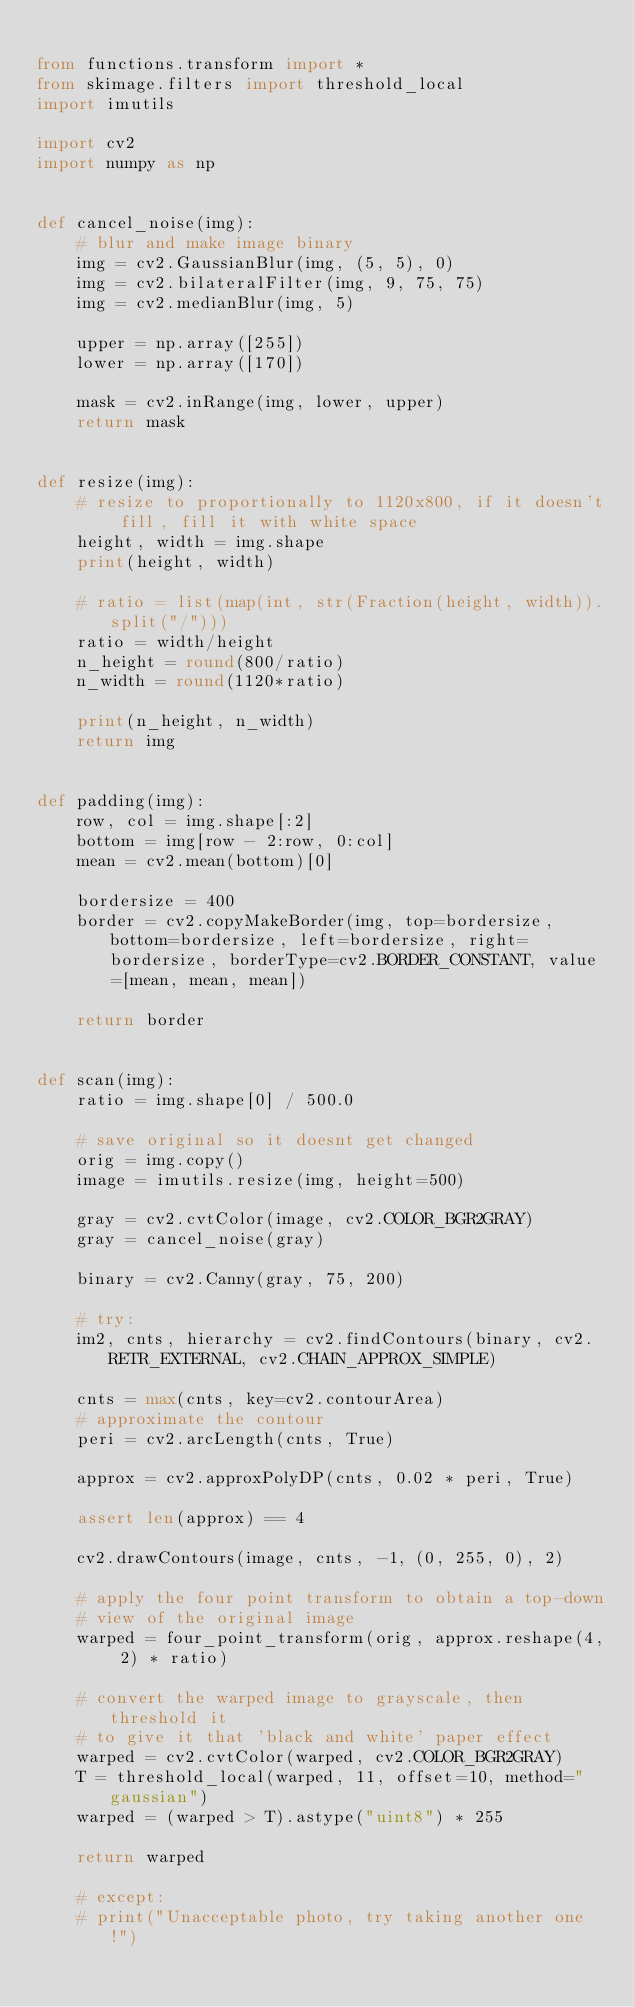<code> <loc_0><loc_0><loc_500><loc_500><_Python_>
from functions.transform import *
from skimage.filters import threshold_local
import imutils

import cv2
import numpy as np


def cancel_noise(img):
    # blur and make image binary
    img = cv2.GaussianBlur(img, (5, 5), 0)
    img = cv2.bilateralFilter(img, 9, 75, 75)
    img = cv2.medianBlur(img, 5)

    upper = np.array([255])
    lower = np.array([170])

    mask = cv2.inRange(img, lower, upper)
    return mask


def resize(img):
    # resize to proportionally to 1120x800, if it doesn't fill, fill it with white space
    height, width = img.shape
    print(height, width)

    # ratio = list(map(int, str(Fraction(height, width)).split("/")))
    ratio = width/height
    n_height = round(800/ratio)
    n_width = round(1120*ratio)

    print(n_height, n_width)
    return img


def padding(img):
    row, col = img.shape[:2]
    bottom = img[row - 2:row, 0:col]
    mean = cv2.mean(bottom)[0]

    bordersize = 400
    border = cv2.copyMakeBorder(img, top=bordersize, bottom=bordersize, left=bordersize, right=bordersize, borderType=cv2.BORDER_CONSTANT, value=[mean, mean, mean])

    return border


def scan(img):
    ratio = img.shape[0] / 500.0

    # save original so it doesnt get changed
    orig = img.copy()
    image = imutils.resize(img, height=500)

    gray = cv2.cvtColor(image, cv2.COLOR_BGR2GRAY)
    gray = cancel_noise(gray)

    binary = cv2.Canny(gray, 75, 200)

    # try:
    im2, cnts, hierarchy = cv2.findContours(binary, cv2.RETR_EXTERNAL, cv2.CHAIN_APPROX_SIMPLE)

    cnts = max(cnts, key=cv2.contourArea)
    # approximate the contour
    peri = cv2.arcLength(cnts, True)

    approx = cv2.approxPolyDP(cnts, 0.02 * peri, True)

    assert len(approx) == 4

    cv2.drawContours(image, cnts, -1, (0, 255, 0), 2)

    # apply the four point transform to obtain a top-down
    # view of the original image
    warped = four_point_transform(orig, approx.reshape(4, 2) * ratio)

    # convert the warped image to grayscale, then threshold it
    # to give it that 'black and white' paper effect
    warped = cv2.cvtColor(warped, cv2.COLOR_BGR2GRAY)
    T = threshold_local(warped, 11, offset=10, method="gaussian")
    warped = (warped > T).astype("uint8") * 255

    return warped

    # except:
    # print("Unacceptable photo, try taking another one!")</code> 